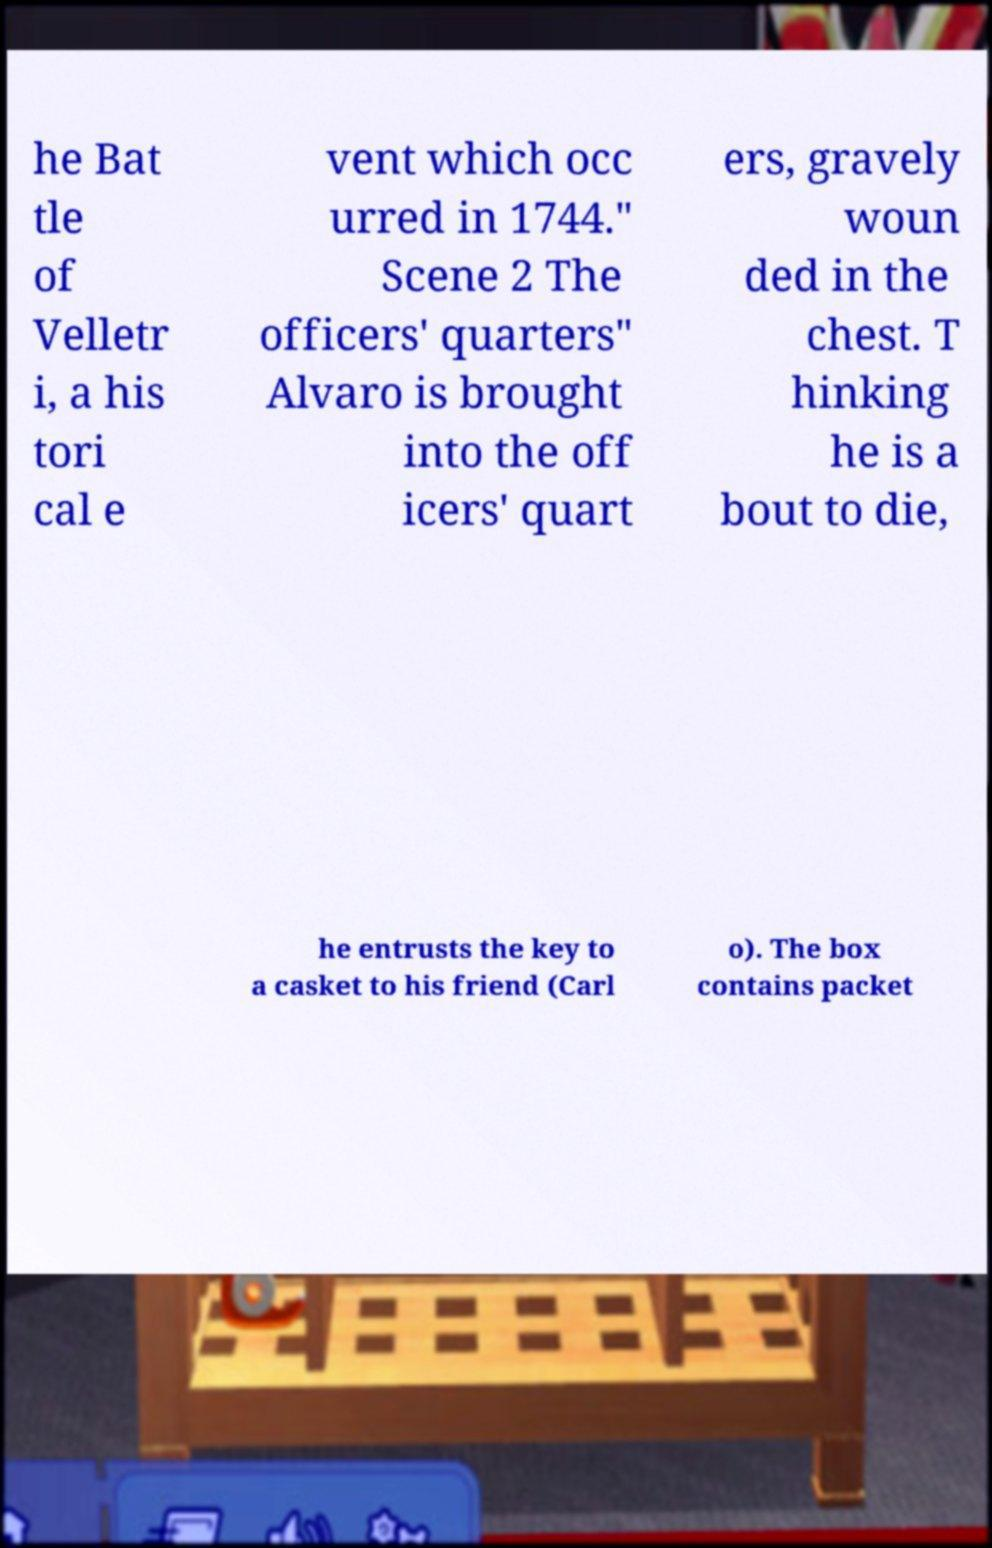For documentation purposes, I need the text within this image transcribed. Could you provide that? he Bat tle of Velletr i, a his tori cal e vent which occ urred in 1744." Scene 2 The officers' quarters" Alvaro is brought into the off icers' quart ers, gravely woun ded in the chest. T hinking he is a bout to die, he entrusts the key to a casket to his friend (Carl o). The box contains packet 